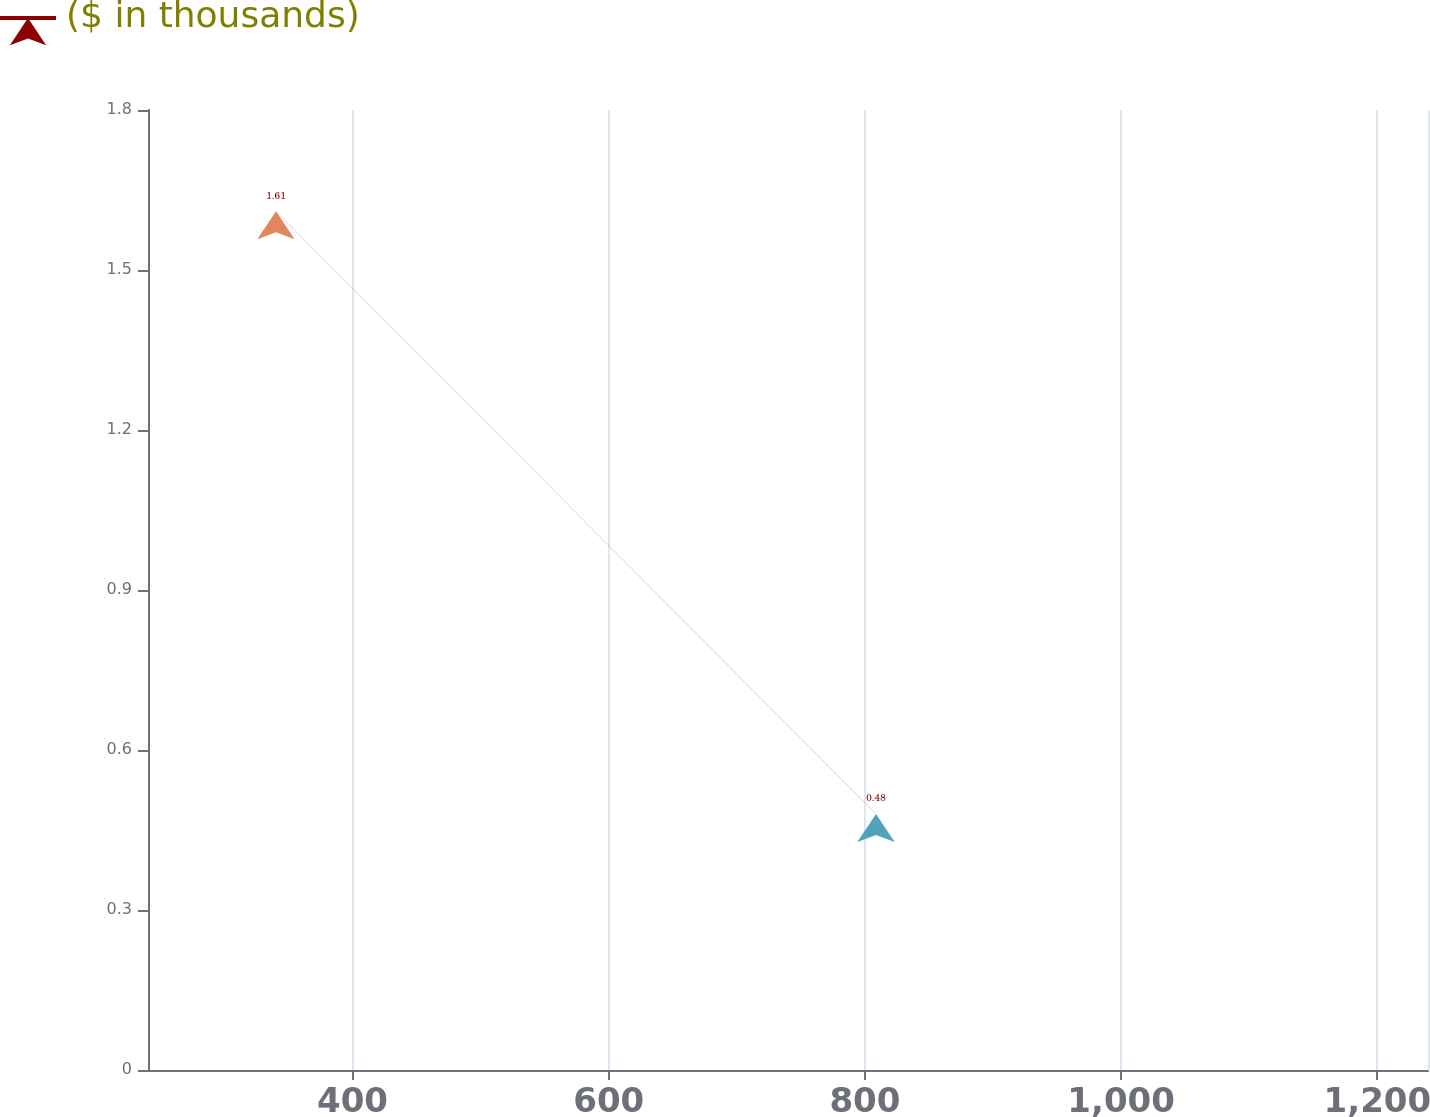<chart> <loc_0><loc_0><loc_500><loc_500><line_chart><ecel><fcel>($ in thousands)<nl><fcel>340.26<fcel>1.61<nl><fcel>808.63<fcel>0.48<nl><fcel>1339.46<fcel>1.96<nl></chart> 